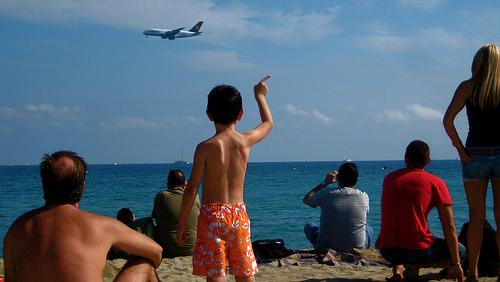Write about the overall atmosphere of the beach scene in the image. People on a beach are enjoying the calm blue water and watching a passenger plane flying in the sky. Explain the scenery near the water in the image. Calm blue sea water shimmers in the distance with a boat sailing and shirtless man sitting in the sand. Narrate an interaction between a young boy and a feature in the sky. A boy in an orange print swimsuit is pointing to the sky as he watches a plane flying above. Describe a man sitting on the beach and his attire. A man in a blue shirt is sitting in the sand, looking out at the calm blue water. Describe an object in the air and its background in the image. An airplane is flying in the sky, surrounded by clouds, while people on the beach look on. Provide a short summary of the major elements featured in the image. A bustling beach scene includes people watching a plane, a boy pointing at the sky, and a man taking a picture. Mention a unique clothing item worn by a young boy in the image. A little boy is wearing orange and white Hawaiian shorts while he points into the sky. Talk about an adult woman standing on the beach. A blonde-haired woman with her left hand in her back pocket is standing on the beach, observing the scene. Mention a man with an activity in the image while describing his clothing. A man wearing a red shirt is kneeling in the sand while taking a picture. Write a brief description of the main event happening at the beach in the image. A little boy wearing orange shorts is pointing at a passenger plane flying in the sky as people on the beach watch. 